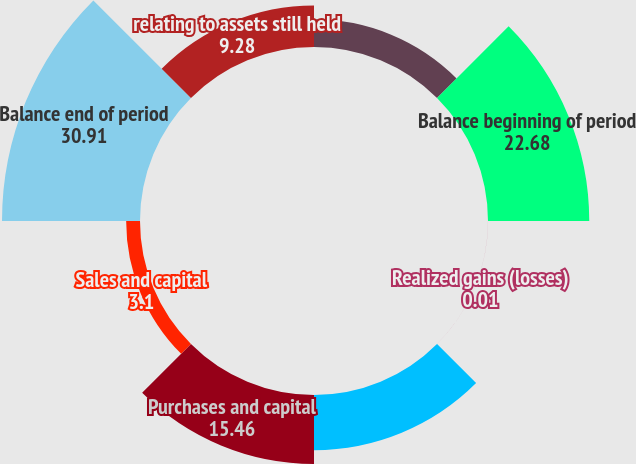Convert chart to OTSL. <chart><loc_0><loc_0><loc_500><loc_500><pie_chart><fcel>(Dollars in thousands)<fcel>Balance beginning of period<fcel>Realized gains (losses)<fcel>Unrealized gains (losses)<fcel>Purchases and capital<fcel>Sales and capital<fcel>Balance end of period<fcel>relating to assets still held<nl><fcel>6.19%<fcel>22.68%<fcel>0.01%<fcel>12.37%<fcel>15.46%<fcel>3.1%<fcel>30.91%<fcel>9.28%<nl></chart> 